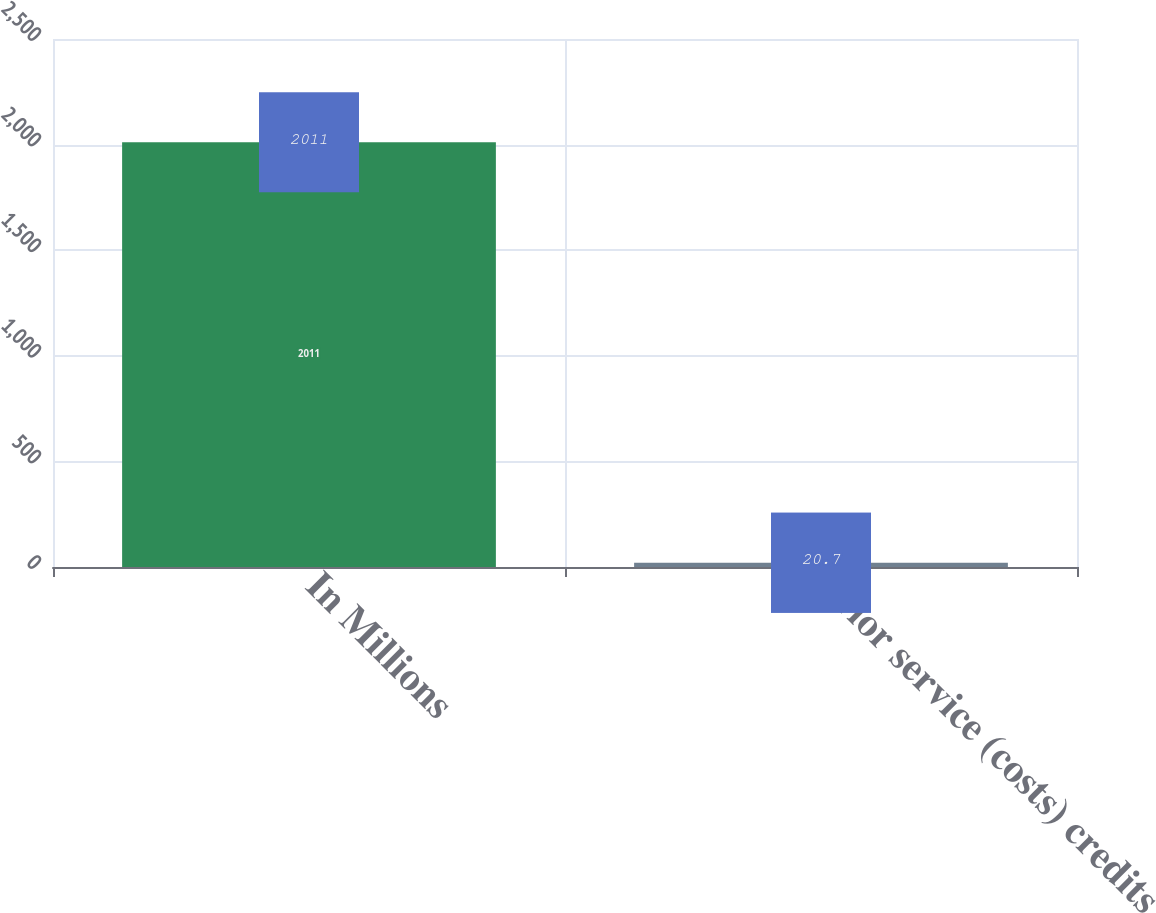Convert chart. <chart><loc_0><loc_0><loc_500><loc_500><bar_chart><fcel>In Millions<fcel>Prior service (costs) credits<nl><fcel>2011<fcel>20.7<nl></chart> 